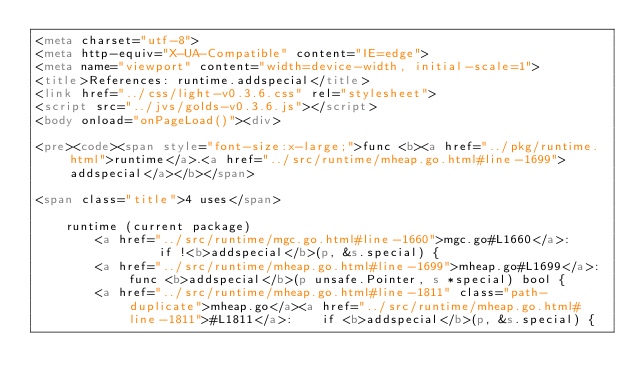Convert code to text. <code><loc_0><loc_0><loc_500><loc_500><_HTML_><meta charset="utf-8">
<meta http-equiv="X-UA-Compatible" content="IE=edge">
<meta name="viewport" content="width=device-width, initial-scale=1">
<title>References: runtime.addspecial</title>
<link href="../css/light-v0.3.6.css" rel="stylesheet">
<script src="../jvs/golds-v0.3.6.js"></script>
<body onload="onPageLoad()"><div>

<pre><code><span style="font-size:x-large;">func <b><a href="../pkg/runtime.html">runtime</a>.<a href="../src/runtime/mheap.go.html#line-1699">addspecial</a></b></span>

<span class="title">4 uses</span>

	runtime (current package)
		<a href="../src/runtime/mgc.go.html#line-1660">mgc.go#L1660</a>: 		if !<b>addspecial</b>(p, &s.special) {
		<a href="../src/runtime/mheap.go.html#line-1699">mheap.go#L1699</a>: func <b>addspecial</b>(p unsafe.Pointer, s *special) bool {
		<a href="../src/runtime/mheap.go.html#line-1811" class="path-duplicate">mheap.go</a><a href="../src/runtime/mheap.go.html#line-1811">#L1811</a>: 	if <b>addspecial</b>(p, &s.special) {</code> 